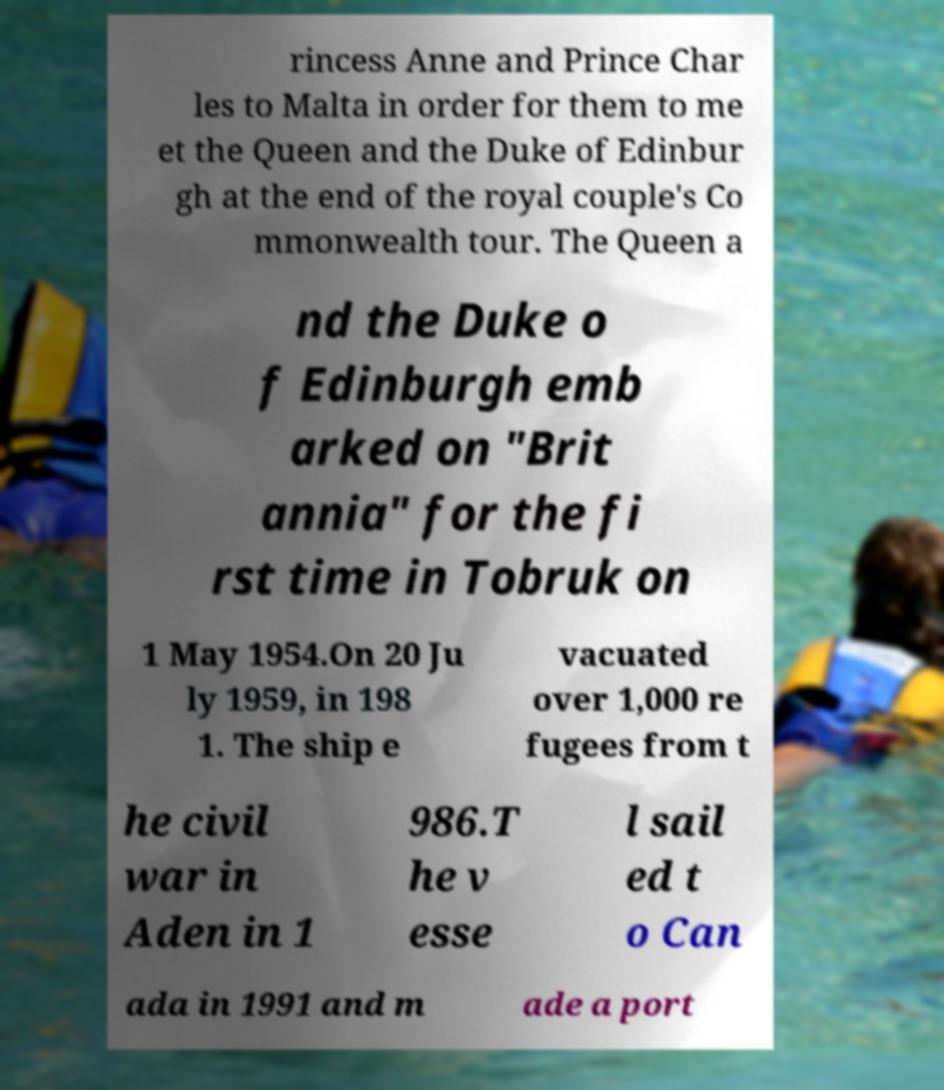I need the written content from this picture converted into text. Can you do that? rincess Anne and Prince Char les to Malta in order for them to me et the Queen and the Duke of Edinbur gh at the end of the royal couple's Co mmonwealth tour. The Queen a nd the Duke o f Edinburgh emb arked on "Brit annia" for the fi rst time in Tobruk on 1 May 1954.On 20 Ju ly 1959, in 198 1. The ship e vacuated over 1,000 re fugees from t he civil war in Aden in 1 986.T he v esse l sail ed t o Can ada in 1991 and m ade a port 